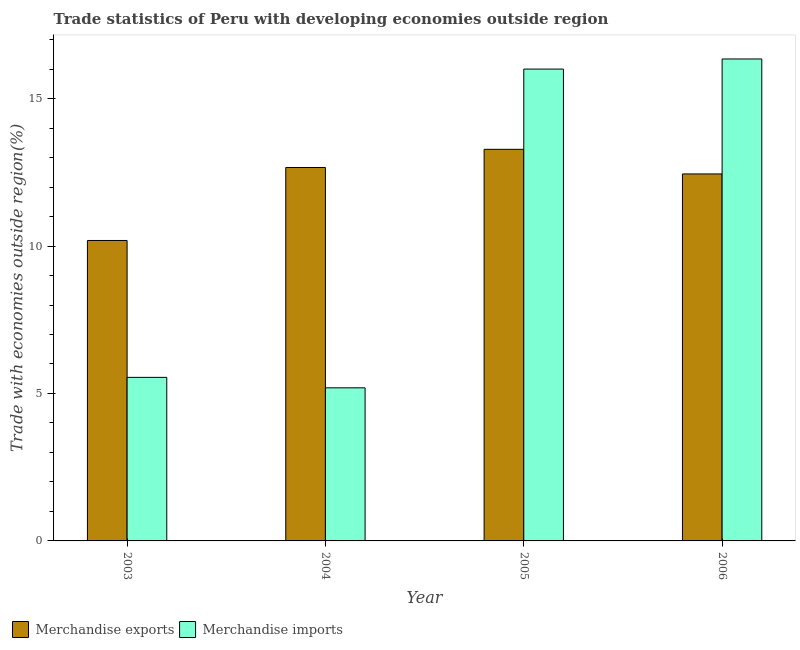How many groups of bars are there?
Give a very brief answer. 4. Are the number of bars per tick equal to the number of legend labels?
Ensure brevity in your answer.  Yes. How many bars are there on the 1st tick from the left?
Provide a short and direct response. 2. How many bars are there on the 3rd tick from the right?
Offer a very short reply. 2. What is the merchandise imports in 2004?
Your answer should be very brief. 5.19. Across all years, what is the maximum merchandise exports?
Provide a short and direct response. 13.28. Across all years, what is the minimum merchandise imports?
Offer a terse response. 5.19. In which year was the merchandise imports maximum?
Your answer should be very brief. 2006. What is the total merchandise exports in the graph?
Give a very brief answer. 48.58. What is the difference between the merchandise imports in 2005 and that in 2006?
Give a very brief answer. -0.34. What is the difference between the merchandise imports in 2005 and the merchandise exports in 2004?
Provide a short and direct response. 10.81. What is the average merchandise exports per year?
Provide a short and direct response. 12.14. What is the ratio of the merchandise exports in 2003 to that in 2005?
Keep it short and to the point. 0.77. Is the difference between the merchandise imports in 2004 and 2005 greater than the difference between the merchandise exports in 2004 and 2005?
Make the answer very short. No. What is the difference between the highest and the second highest merchandise exports?
Provide a succinct answer. 0.62. What is the difference between the highest and the lowest merchandise imports?
Offer a very short reply. 11.15. What does the 2nd bar from the right in 2003 represents?
Your answer should be compact. Merchandise exports. How many bars are there?
Provide a short and direct response. 8. How many years are there in the graph?
Ensure brevity in your answer.  4. Are the values on the major ticks of Y-axis written in scientific E-notation?
Offer a terse response. No. Does the graph contain any zero values?
Give a very brief answer. No. How are the legend labels stacked?
Keep it short and to the point. Horizontal. What is the title of the graph?
Your answer should be compact. Trade statistics of Peru with developing economies outside region. What is the label or title of the Y-axis?
Provide a short and direct response. Trade with economies outside region(%). What is the Trade with economies outside region(%) in Merchandise exports in 2003?
Make the answer very short. 10.19. What is the Trade with economies outside region(%) in Merchandise imports in 2003?
Offer a very short reply. 5.55. What is the Trade with economies outside region(%) of Merchandise exports in 2004?
Your response must be concise. 12.66. What is the Trade with economies outside region(%) in Merchandise imports in 2004?
Offer a terse response. 5.19. What is the Trade with economies outside region(%) of Merchandise exports in 2005?
Offer a terse response. 13.28. What is the Trade with economies outside region(%) of Merchandise imports in 2005?
Give a very brief answer. 16. What is the Trade with economies outside region(%) in Merchandise exports in 2006?
Your response must be concise. 12.45. What is the Trade with economies outside region(%) in Merchandise imports in 2006?
Offer a very short reply. 16.34. Across all years, what is the maximum Trade with economies outside region(%) of Merchandise exports?
Ensure brevity in your answer.  13.28. Across all years, what is the maximum Trade with economies outside region(%) of Merchandise imports?
Offer a very short reply. 16.34. Across all years, what is the minimum Trade with economies outside region(%) of Merchandise exports?
Offer a very short reply. 10.19. Across all years, what is the minimum Trade with economies outside region(%) of Merchandise imports?
Your answer should be compact. 5.19. What is the total Trade with economies outside region(%) of Merchandise exports in the graph?
Make the answer very short. 48.58. What is the total Trade with economies outside region(%) of Merchandise imports in the graph?
Ensure brevity in your answer.  43.08. What is the difference between the Trade with economies outside region(%) in Merchandise exports in 2003 and that in 2004?
Your answer should be very brief. -2.48. What is the difference between the Trade with economies outside region(%) of Merchandise imports in 2003 and that in 2004?
Provide a succinct answer. 0.35. What is the difference between the Trade with economies outside region(%) of Merchandise exports in 2003 and that in 2005?
Provide a succinct answer. -3.09. What is the difference between the Trade with economies outside region(%) of Merchandise imports in 2003 and that in 2005?
Your answer should be compact. -10.46. What is the difference between the Trade with economies outside region(%) in Merchandise exports in 2003 and that in 2006?
Your answer should be compact. -2.26. What is the difference between the Trade with economies outside region(%) in Merchandise imports in 2003 and that in 2006?
Your answer should be very brief. -10.8. What is the difference between the Trade with economies outside region(%) of Merchandise exports in 2004 and that in 2005?
Provide a succinct answer. -0.62. What is the difference between the Trade with economies outside region(%) of Merchandise imports in 2004 and that in 2005?
Offer a terse response. -10.81. What is the difference between the Trade with economies outside region(%) of Merchandise exports in 2004 and that in 2006?
Your answer should be very brief. 0.22. What is the difference between the Trade with economies outside region(%) in Merchandise imports in 2004 and that in 2006?
Provide a succinct answer. -11.15. What is the difference between the Trade with economies outside region(%) in Merchandise exports in 2005 and that in 2006?
Make the answer very short. 0.83. What is the difference between the Trade with economies outside region(%) in Merchandise imports in 2005 and that in 2006?
Your answer should be very brief. -0.34. What is the difference between the Trade with economies outside region(%) in Merchandise exports in 2003 and the Trade with economies outside region(%) in Merchandise imports in 2004?
Your answer should be compact. 5. What is the difference between the Trade with economies outside region(%) of Merchandise exports in 2003 and the Trade with economies outside region(%) of Merchandise imports in 2005?
Provide a succinct answer. -5.81. What is the difference between the Trade with economies outside region(%) of Merchandise exports in 2003 and the Trade with economies outside region(%) of Merchandise imports in 2006?
Offer a very short reply. -6.16. What is the difference between the Trade with economies outside region(%) in Merchandise exports in 2004 and the Trade with economies outside region(%) in Merchandise imports in 2005?
Offer a terse response. -3.34. What is the difference between the Trade with economies outside region(%) of Merchandise exports in 2004 and the Trade with economies outside region(%) of Merchandise imports in 2006?
Give a very brief answer. -3.68. What is the difference between the Trade with economies outside region(%) of Merchandise exports in 2005 and the Trade with economies outside region(%) of Merchandise imports in 2006?
Make the answer very short. -3.06. What is the average Trade with economies outside region(%) in Merchandise exports per year?
Ensure brevity in your answer.  12.14. What is the average Trade with economies outside region(%) in Merchandise imports per year?
Ensure brevity in your answer.  10.77. In the year 2003, what is the difference between the Trade with economies outside region(%) of Merchandise exports and Trade with economies outside region(%) of Merchandise imports?
Your answer should be compact. 4.64. In the year 2004, what is the difference between the Trade with economies outside region(%) of Merchandise exports and Trade with economies outside region(%) of Merchandise imports?
Provide a succinct answer. 7.47. In the year 2005, what is the difference between the Trade with economies outside region(%) of Merchandise exports and Trade with economies outside region(%) of Merchandise imports?
Your answer should be compact. -2.72. In the year 2006, what is the difference between the Trade with economies outside region(%) in Merchandise exports and Trade with economies outside region(%) in Merchandise imports?
Keep it short and to the point. -3.9. What is the ratio of the Trade with economies outside region(%) of Merchandise exports in 2003 to that in 2004?
Keep it short and to the point. 0.8. What is the ratio of the Trade with economies outside region(%) in Merchandise imports in 2003 to that in 2004?
Your response must be concise. 1.07. What is the ratio of the Trade with economies outside region(%) in Merchandise exports in 2003 to that in 2005?
Your response must be concise. 0.77. What is the ratio of the Trade with economies outside region(%) of Merchandise imports in 2003 to that in 2005?
Ensure brevity in your answer.  0.35. What is the ratio of the Trade with economies outside region(%) in Merchandise exports in 2003 to that in 2006?
Offer a very short reply. 0.82. What is the ratio of the Trade with economies outside region(%) of Merchandise imports in 2003 to that in 2006?
Give a very brief answer. 0.34. What is the ratio of the Trade with economies outside region(%) of Merchandise exports in 2004 to that in 2005?
Make the answer very short. 0.95. What is the ratio of the Trade with economies outside region(%) in Merchandise imports in 2004 to that in 2005?
Make the answer very short. 0.32. What is the ratio of the Trade with economies outside region(%) in Merchandise exports in 2004 to that in 2006?
Provide a succinct answer. 1.02. What is the ratio of the Trade with economies outside region(%) of Merchandise imports in 2004 to that in 2006?
Offer a terse response. 0.32. What is the ratio of the Trade with economies outside region(%) in Merchandise exports in 2005 to that in 2006?
Keep it short and to the point. 1.07. What is the ratio of the Trade with economies outside region(%) of Merchandise imports in 2005 to that in 2006?
Offer a terse response. 0.98. What is the difference between the highest and the second highest Trade with economies outside region(%) of Merchandise exports?
Give a very brief answer. 0.62. What is the difference between the highest and the second highest Trade with economies outside region(%) in Merchandise imports?
Ensure brevity in your answer.  0.34. What is the difference between the highest and the lowest Trade with economies outside region(%) in Merchandise exports?
Ensure brevity in your answer.  3.09. What is the difference between the highest and the lowest Trade with economies outside region(%) in Merchandise imports?
Make the answer very short. 11.15. 